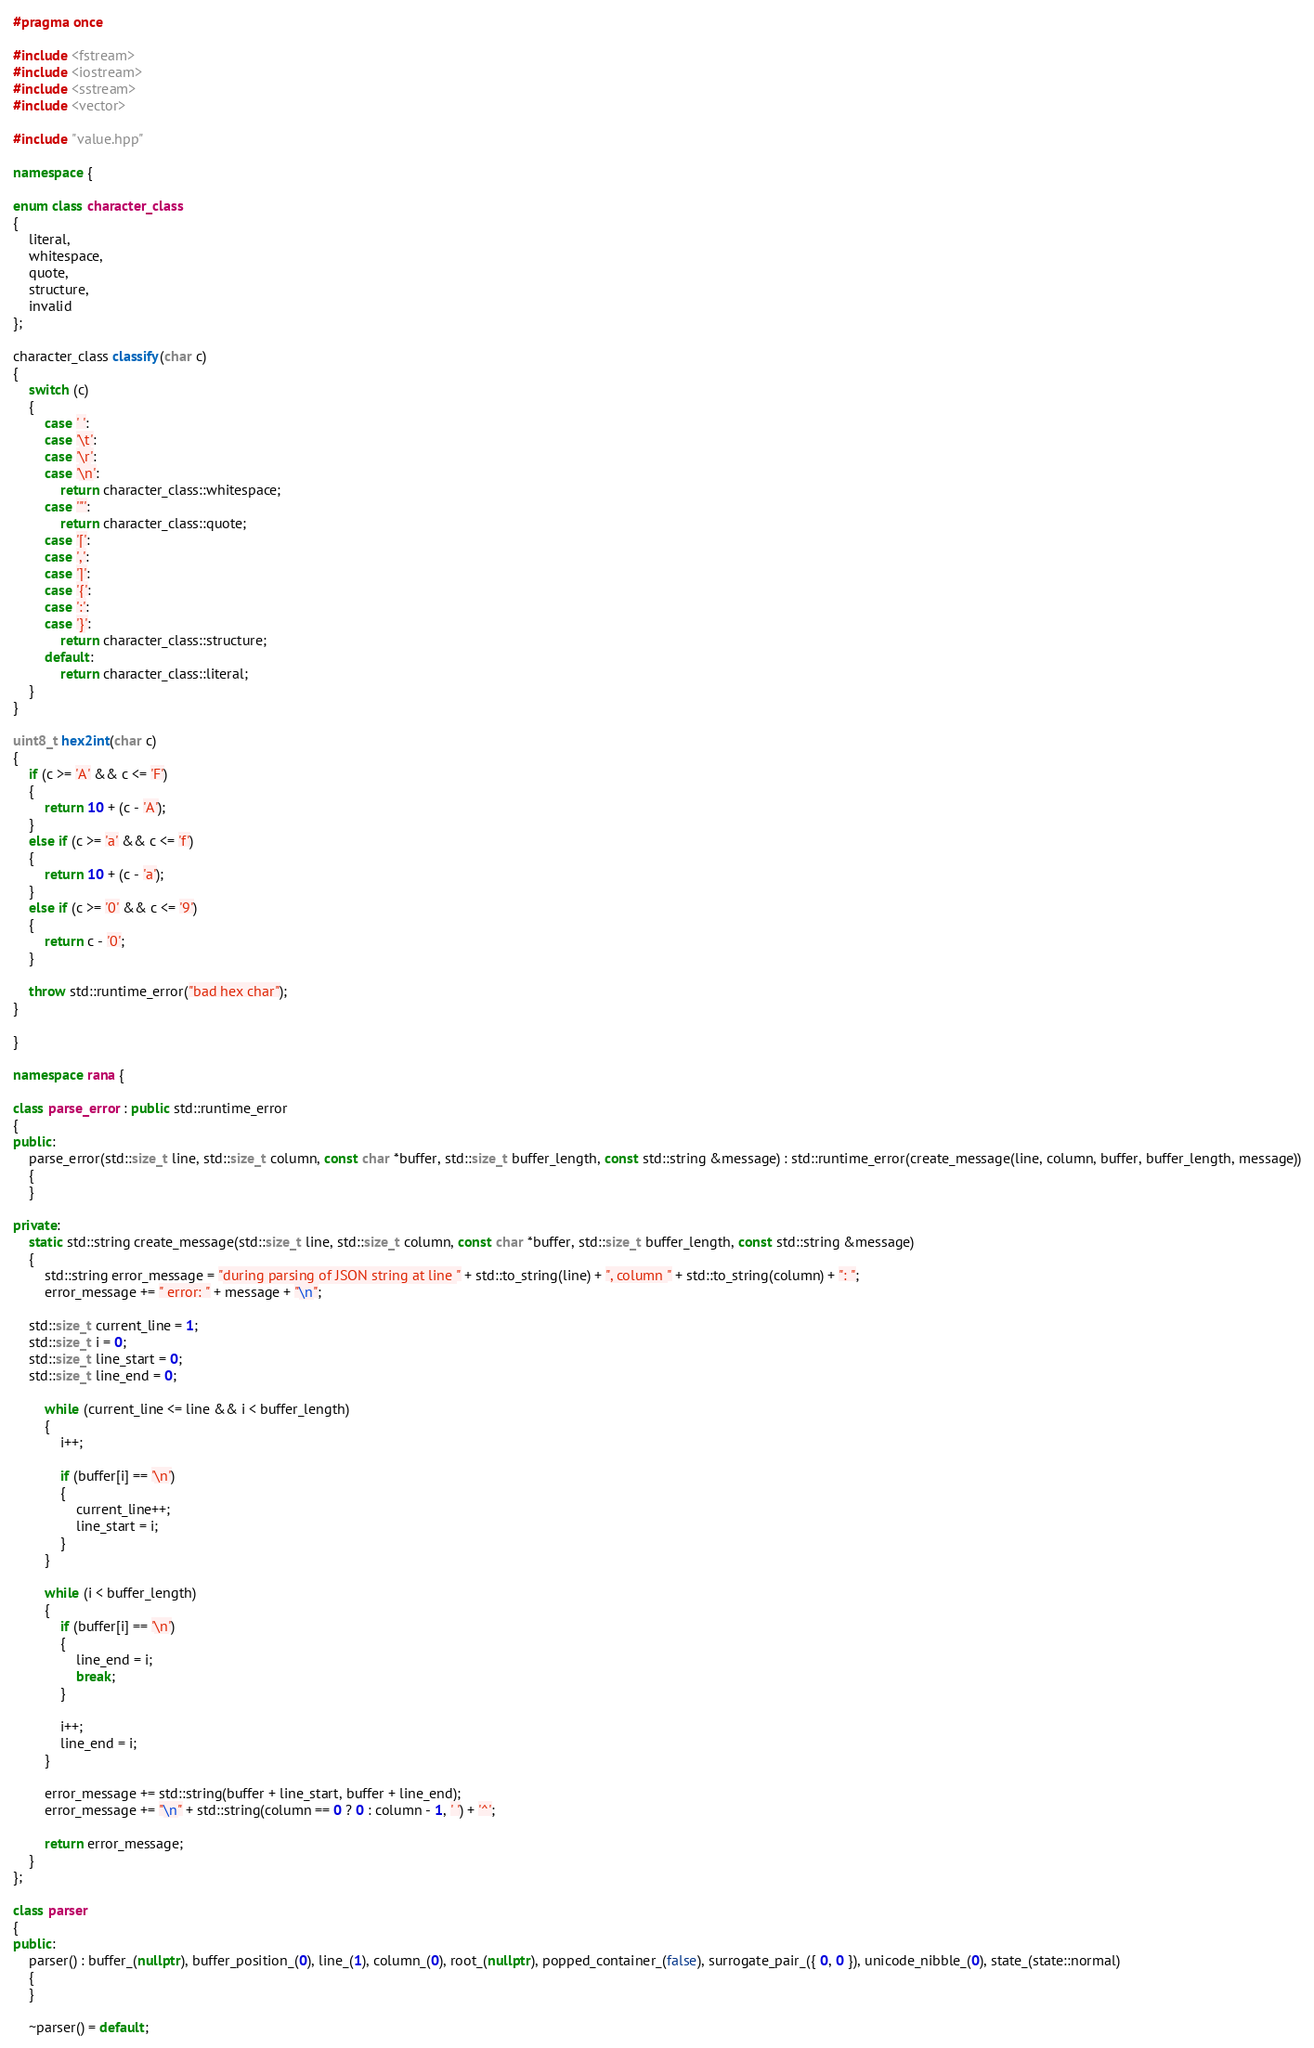Convert code to text. <code><loc_0><loc_0><loc_500><loc_500><_C++_>#pragma once

#include <fstream>
#include <iostream>
#include <sstream>
#include <vector>

#include "value.hpp"

namespace {

enum class character_class
{
    literal,
    whitespace,
    quote,
    structure,
    invalid
};

character_class classify(char c)
{
    switch (c)
    {
        case ' ':
        case '\t':
        case '\r':
        case '\n':
            return character_class::whitespace;
        case '"':
            return character_class::quote;
        case '[':
        case ',':
        case ']':
        case '{':
        case ':':
        case '}':
            return character_class::structure;
        default:
            return character_class::literal;
    }
}
    
uint8_t hex2int(char c)
{
    if (c >= 'A' && c <= 'F')
    {
        return 10 + (c - 'A');
    }
    else if (c >= 'a' && c <= 'f')
    {
        return 10 + (c - 'a');
    }
    else if (c >= '0' && c <= '9')
    {
        return c - '0';
    }
    
    throw std::runtime_error("bad hex char");
}
    
}

namespace rana {

class parse_error : public std::runtime_error
{
public:
    parse_error(std::size_t line, std::size_t column, const char *buffer, std::size_t buffer_length, const std::string &message) : std::runtime_error(create_message(line, column, buffer, buffer_length, message))
    {
    }
    
private:
	static std::string create_message(std::size_t line, std::size_t column, const char *buffer, std::size_t buffer_length, const std::string &message)
    {
        std::string error_message = "during parsing of JSON string at line " + std::to_string(line) + ", column " + std::to_string(column) + ": ";
        error_message += " error: " + message + "\n";
        
	std::size_t current_line = 1;
	std::size_t i = 0;
	std::size_t line_start = 0;
	std::size_t line_end = 0;
        
        while (current_line <= line && i < buffer_length)
        {
            i++;
            
            if (buffer[i] == '\n')
            {
                current_line++;
                line_start = i;
            }
        }
        
        while (i < buffer_length)
        {
            if (buffer[i] == '\n')
            {
                line_end = i;
                break;
            }
            
            i++;
            line_end = i;
        }
        
        error_message += std::string(buffer + line_start, buffer + line_end);
        error_message += "\n" + std::string(column == 0 ? 0 : column - 1, ' ') + '^';
        
        return error_message;
    }
};

class parser
{
public:
    parser() : buffer_(nullptr), buffer_position_(0), line_(1), column_(0), root_(nullptr), popped_container_(false), surrogate_pair_({ 0, 0 }), unicode_nibble_(0), state_(state::normal)
    {
    }
    
	~parser() = default;
</code> 